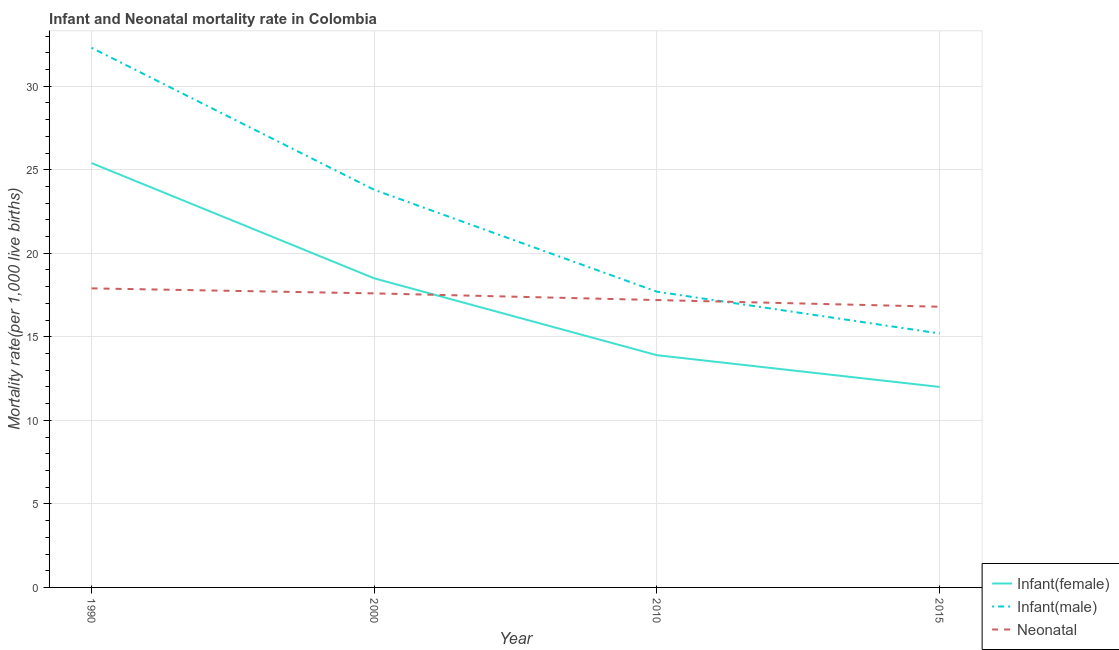Does the line corresponding to infant mortality rate(male) intersect with the line corresponding to neonatal mortality rate?
Your answer should be very brief. Yes. What is the infant mortality rate(male) in 1990?
Your answer should be very brief. 32.3. Across all years, what is the maximum infant mortality rate(female)?
Give a very brief answer. 25.4. Across all years, what is the minimum infant mortality rate(female)?
Give a very brief answer. 12. In which year was the infant mortality rate(male) maximum?
Your answer should be very brief. 1990. In which year was the infant mortality rate(female) minimum?
Your answer should be compact. 2015. What is the total infant mortality rate(male) in the graph?
Keep it short and to the point. 89. What is the difference between the infant mortality rate(male) in 1990 and that in 2000?
Ensure brevity in your answer.  8.5. What is the average infant mortality rate(male) per year?
Your answer should be compact. 22.25. In the year 2015, what is the difference between the infant mortality rate(male) and infant mortality rate(female)?
Your answer should be very brief. 3.2. What is the ratio of the infant mortality rate(female) in 1990 to that in 2000?
Provide a short and direct response. 1.37. Is the difference between the infant mortality rate(female) in 2000 and 2015 greater than the difference between the infant mortality rate(male) in 2000 and 2015?
Ensure brevity in your answer.  No. What is the difference between the highest and the second highest infant mortality rate(male)?
Provide a succinct answer. 8.5. What is the difference between the highest and the lowest infant mortality rate(male)?
Offer a very short reply. 17.1. Is the sum of the neonatal mortality rate in 1990 and 2015 greater than the maximum infant mortality rate(female) across all years?
Give a very brief answer. Yes. Is it the case that in every year, the sum of the infant mortality rate(female) and infant mortality rate(male) is greater than the neonatal mortality rate?
Keep it short and to the point. Yes. Does the infant mortality rate(male) monotonically increase over the years?
Offer a very short reply. No. How many years are there in the graph?
Make the answer very short. 4. What is the difference between two consecutive major ticks on the Y-axis?
Give a very brief answer. 5. Are the values on the major ticks of Y-axis written in scientific E-notation?
Provide a succinct answer. No. Does the graph contain grids?
Offer a terse response. Yes. What is the title of the graph?
Your response must be concise. Infant and Neonatal mortality rate in Colombia. What is the label or title of the Y-axis?
Your answer should be very brief. Mortality rate(per 1,0 live births). What is the Mortality rate(per 1,000 live births) in Infant(female) in 1990?
Offer a very short reply. 25.4. What is the Mortality rate(per 1,000 live births) of Infant(male) in 1990?
Keep it short and to the point. 32.3. What is the Mortality rate(per 1,000 live births) of Infant(female) in 2000?
Offer a terse response. 18.5. What is the Mortality rate(per 1,000 live births) in Infant(male) in 2000?
Provide a succinct answer. 23.8. What is the Mortality rate(per 1,000 live births) in Infant(female) in 2010?
Offer a terse response. 13.9. What is the Mortality rate(per 1,000 live births) in Neonatal  in 2015?
Give a very brief answer. 16.8. Across all years, what is the maximum Mortality rate(per 1,000 live births) of Infant(female)?
Ensure brevity in your answer.  25.4. Across all years, what is the maximum Mortality rate(per 1,000 live births) of Infant(male)?
Provide a succinct answer. 32.3. Across all years, what is the maximum Mortality rate(per 1,000 live births) in Neonatal ?
Keep it short and to the point. 17.9. Across all years, what is the minimum Mortality rate(per 1,000 live births) in Infant(male)?
Provide a succinct answer. 15.2. Across all years, what is the minimum Mortality rate(per 1,000 live births) in Neonatal ?
Provide a short and direct response. 16.8. What is the total Mortality rate(per 1,000 live births) of Infant(female) in the graph?
Keep it short and to the point. 69.8. What is the total Mortality rate(per 1,000 live births) in Infant(male) in the graph?
Your response must be concise. 89. What is the total Mortality rate(per 1,000 live births) in Neonatal  in the graph?
Keep it short and to the point. 69.5. What is the difference between the Mortality rate(per 1,000 live births) in Infant(female) in 1990 and that in 2000?
Provide a short and direct response. 6.9. What is the difference between the Mortality rate(per 1,000 live births) of Infant(male) in 1990 and that in 2000?
Your answer should be very brief. 8.5. What is the difference between the Mortality rate(per 1,000 live births) in Infant(male) in 1990 and that in 2015?
Provide a short and direct response. 17.1. What is the difference between the Mortality rate(per 1,000 live births) in Neonatal  in 1990 and that in 2015?
Keep it short and to the point. 1.1. What is the difference between the Mortality rate(per 1,000 live births) of Infant(female) in 2000 and that in 2015?
Your answer should be compact. 6.5. What is the difference between the Mortality rate(per 1,000 live births) of Neonatal  in 2000 and that in 2015?
Give a very brief answer. 0.8. What is the difference between the Mortality rate(per 1,000 live births) in Infant(female) in 1990 and the Mortality rate(per 1,000 live births) in Infant(male) in 2000?
Ensure brevity in your answer.  1.6. What is the difference between the Mortality rate(per 1,000 live births) of Infant(female) in 1990 and the Mortality rate(per 1,000 live births) of Neonatal  in 2000?
Your response must be concise. 7.8. What is the difference between the Mortality rate(per 1,000 live births) of Infant(male) in 1990 and the Mortality rate(per 1,000 live births) of Neonatal  in 2000?
Make the answer very short. 14.7. What is the difference between the Mortality rate(per 1,000 live births) in Infant(female) in 1990 and the Mortality rate(per 1,000 live births) in Infant(male) in 2010?
Your answer should be compact. 7.7. What is the difference between the Mortality rate(per 1,000 live births) in Infant(female) in 1990 and the Mortality rate(per 1,000 live births) in Neonatal  in 2010?
Your answer should be very brief. 8.2. What is the difference between the Mortality rate(per 1,000 live births) in Infant(male) in 1990 and the Mortality rate(per 1,000 live births) in Neonatal  in 2010?
Offer a terse response. 15.1. What is the difference between the Mortality rate(per 1,000 live births) in Infant(female) in 1990 and the Mortality rate(per 1,000 live births) in Infant(male) in 2015?
Offer a very short reply. 10.2. What is the difference between the Mortality rate(per 1,000 live births) of Infant(female) in 1990 and the Mortality rate(per 1,000 live births) of Neonatal  in 2015?
Your answer should be compact. 8.6. What is the difference between the Mortality rate(per 1,000 live births) of Infant(female) in 2000 and the Mortality rate(per 1,000 live births) of Infant(male) in 2010?
Your answer should be very brief. 0.8. What is the difference between the Mortality rate(per 1,000 live births) in Infant(male) in 2000 and the Mortality rate(per 1,000 live births) in Neonatal  in 2010?
Offer a very short reply. 6.6. What is the difference between the Mortality rate(per 1,000 live births) of Infant(female) in 2000 and the Mortality rate(per 1,000 live births) of Neonatal  in 2015?
Your answer should be very brief. 1.7. What is the difference between the Mortality rate(per 1,000 live births) of Infant(female) in 2010 and the Mortality rate(per 1,000 live births) of Neonatal  in 2015?
Make the answer very short. -2.9. What is the difference between the Mortality rate(per 1,000 live births) in Infant(male) in 2010 and the Mortality rate(per 1,000 live births) in Neonatal  in 2015?
Your answer should be very brief. 0.9. What is the average Mortality rate(per 1,000 live births) of Infant(female) per year?
Give a very brief answer. 17.45. What is the average Mortality rate(per 1,000 live births) of Infant(male) per year?
Your answer should be very brief. 22.25. What is the average Mortality rate(per 1,000 live births) of Neonatal  per year?
Your answer should be compact. 17.38. In the year 2000, what is the difference between the Mortality rate(per 1,000 live births) in Infant(female) and Mortality rate(per 1,000 live births) in Infant(male)?
Provide a succinct answer. -5.3. In the year 2000, what is the difference between the Mortality rate(per 1,000 live births) in Infant(male) and Mortality rate(per 1,000 live births) in Neonatal ?
Make the answer very short. 6.2. In the year 2010, what is the difference between the Mortality rate(per 1,000 live births) of Infant(female) and Mortality rate(per 1,000 live births) of Neonatal ?
Keep it short and to the point. -3.3. In the year 2010, what is the difference between the Mortality rate(per 1,000 live births) of Infant(male) and Mortality rate(per 1,000 live births) of Neonatal ?
Make the answer very short. 0.5. In the year 2015, what is the difference between the Mortality rate(per 1,000 live births) of Infant(female) and Mortality rate(per 1,000 live births) of Infant(male)?
Keep it short and to the point. -3.2. In the year 2015, what is the difference between the Mortality rate(per 1,000 live births) in Infant(female) and Mortality rate(per 1,000 live births) in Neonatal ?
Keep it short and to the point. -4.8. What is the ratio of the Mortality rate(per 1,000 live births) of Infant(female) in 1990 to that in 2000?
Keep it short and to the point. 1.37. What is the ratio of the Mortality rate(per 1,000 live births) of Infant(male) in 1990 to that in 2000?
Your answer should be compact. 1.36. What is the ratio of the Mortality rate(per 1,000 live births) of Infant(female) in 1990 to that in 2010?
Offer a very short reply. 1.83. What is the ratio of the Mortality rate(per 1,000 live births) of Infant(male) in 1990 to that in 2010?
Provide a short and direct response. 1.82. What is the ratio of the Mortality rate(per 1,000 live births) of Neonatal  in 1990 to that in 2010?
Your response must be concise. 1.04. What is the ratio of the Mortality rate(per 1,000 live births) in Infant(female) in 1990 to that in 2015?
Your answer should be very brief. 2.12. What is the ratio of the Mortality rate(per 1,000 live births) in Infant(male) in 1990 to that in 2015?
Provide a succinct answer. 2.12. What is the ratio of the Mortality rate(per 1,000 live births) in Neonatal  in 1990 to that in 2015?
Your response must be concise. 1.07. What is the ratio of the Mortality rate(per 1,000 live births) of Infant(female) in 2000 to that in 2010?
Give a very brief answer. 1.33. What is the ratio of the Mortality rate(per 1,000 live births) in Infant(male) in 2000 to that in 2010?
Give a very brief answer. 1.34. What is the ratio of the Mortality rate(per 1,000 live births) in Neonatal  in 2000 to that in 2010?
Your answer should be compact. 1.02. What is the ratio of the Mortality rate(per 1,000 live births) of Infant(female) in 2000 to that in 2015?
Make the answer very short. 1.54. What is the ratio of the Mortality rate(per 1,000 live births) in Infant(male) in 2000 to that in 2015?
Keep it short and to the point. 1.57. What is the ratio of the Mortality rate(per 1,000 live births) in Neonatal  in 2000 to that in 2015?
Provide a succinct answer. 1.05. What is the ratio of the Mortality rate(per 1,000 live births) in Infant(female) in 2010 to that in 2015?
Ensure brevity in your answer.  1.16. What is the ratio of the Mortality rate(per 1,000 live births) of Infant(male) in 2010 to that in 2015?
Ensure brevity in your answer.  1.16. What is the ratio of the Mortality rate(per 1,000 live births) of Neonatal  in 2010 to that in 2015?
Provide a short and direct response. 1.02. What is the difference between the highest and the second highest Mortality rate(per 1,000 live births) of Infant(female)?
Make the answer very short. 6.9. What is the difference between the highest and the second highest Mortality rate(per 1,000 live births) in Infant(male)?
Your response must be concise. 8.5. What is the difference between the highest and the second highest Mortality rate(per 1,000 live births) in Neonatal ?
Your answer should be very brief. 0.3. What is the difference between the highest and the lowest Mortality rate(per 1,000 live births) of Infant(male)?
Your answer should be compact. 17.1. What is the difference between the highest and the lowest Mortality rate(per 1,000 live births) in Neonatal ?
Make the answer very short. 1.1. 